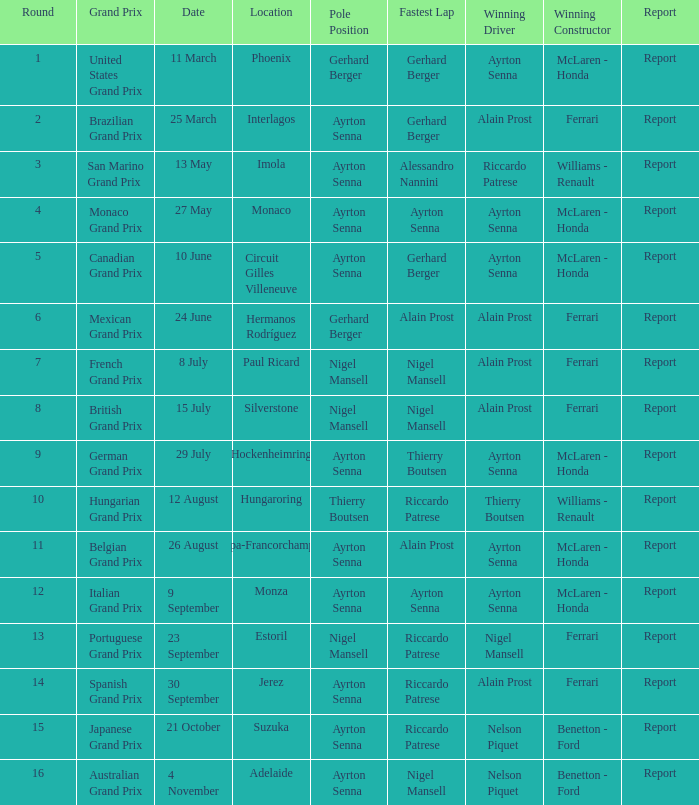What is the Pole Position for the German Grand Prix Ayrton Senna. 